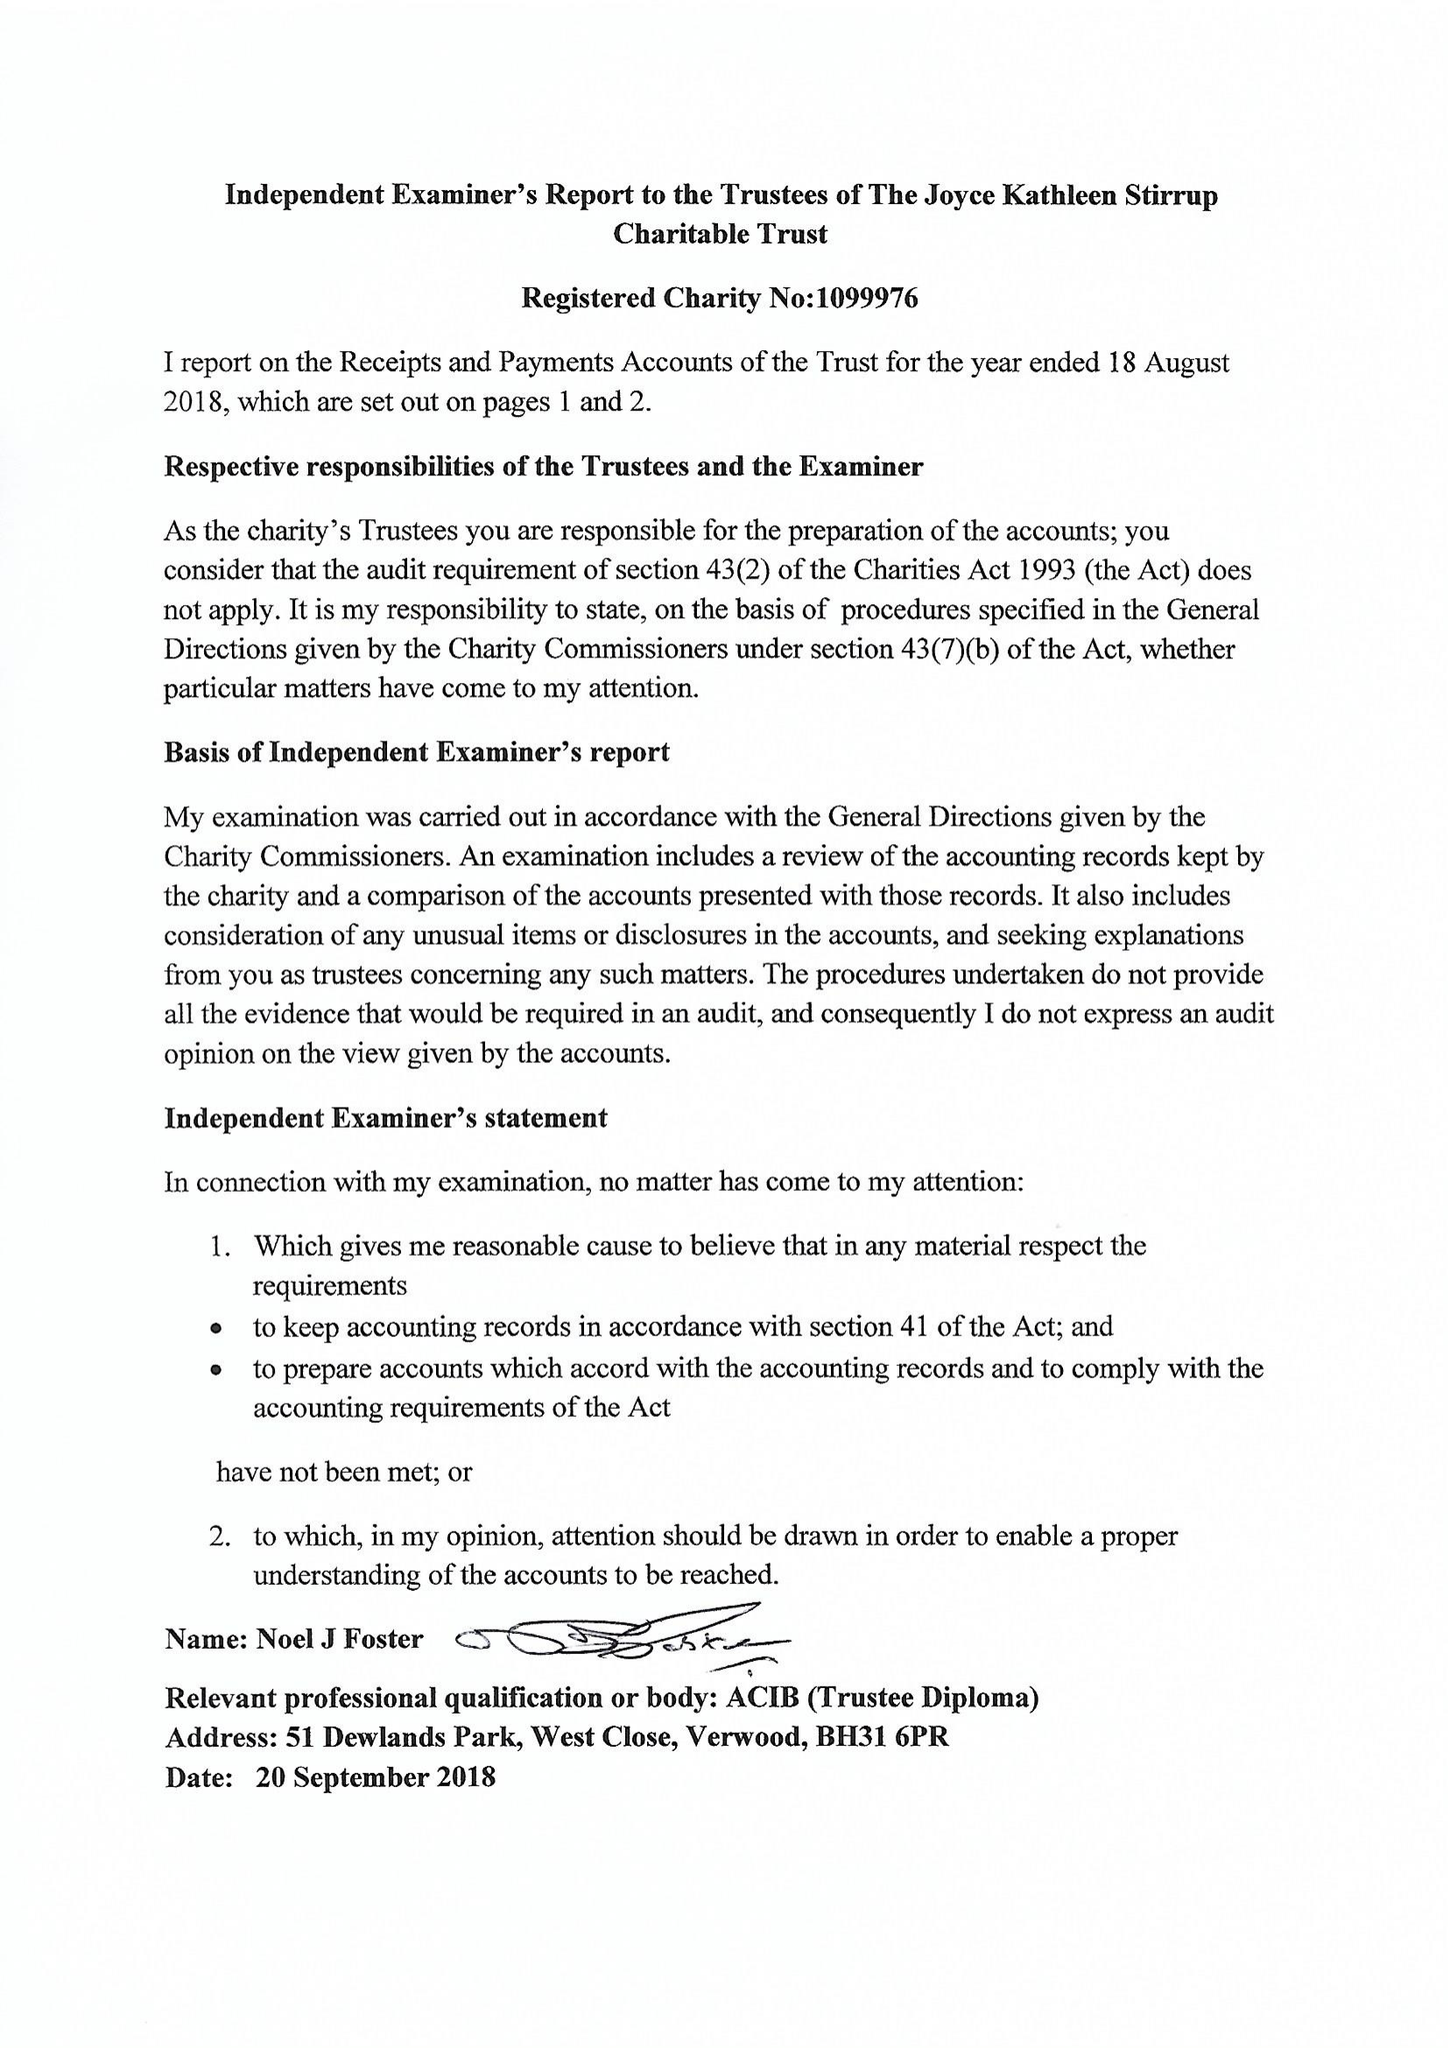What is the value for the charity_number?
Answer the question using a single word or phrase. 1099976 